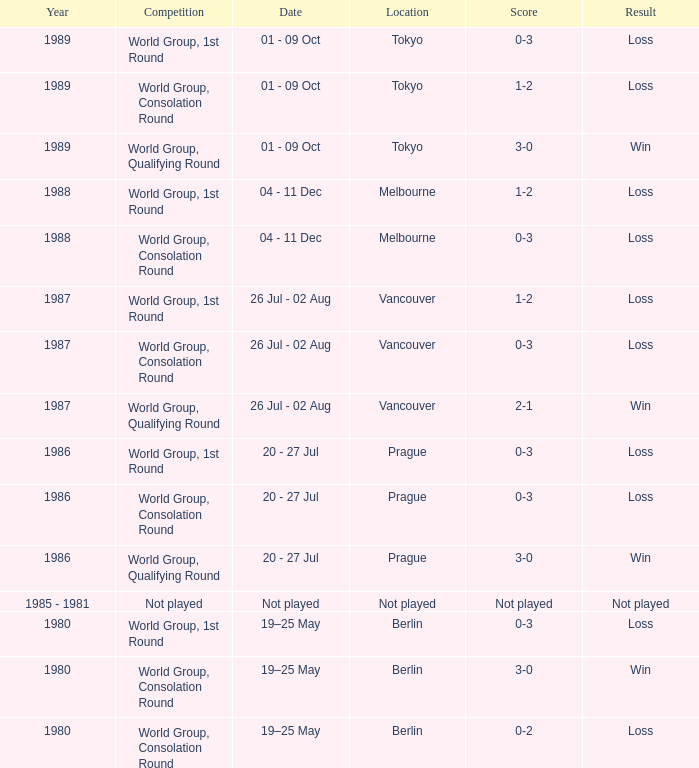What is the competition in tokyo with the result loss? World Group, 1st Round, World Group, Consolation Round. Would you be able to parse every entry in this table? {'header': ['Year', 'Competition', 'Date', 'Location', 'Score', 'Result'], 'rows': [['1989', 'World Group, 1st Round', '01 - 09 Oct', 'Tokyo', '0-3', 'Loss'], ['1989', 'World Group, Consolation Round', '01 - 09 Oct', 'Tokyo', '1-2', 'Loss'], ['1989', 'World Group, Qualifying Round', '01 - 09 Oct', 'Tokyo', '3-0', 'Win'], ['1988', 'World Group, 1st Round', '04 - 11 Dec', 'Melbourne', '1-2', 'Loss'], ['1988', 'World Group, Consolation Round', '04 - 11 Dec', 'Melbourne', '0-3', 'Loss'], ['1987', 'World Group, 1st Round', '26 Jul - 02 Aug', 'Vancouver', '1-2', 'Loss'], ['1987', 'World Group, Consolation Round', '26 Jul - 02 Aug', 'Vancouver', '0-3', 'Loss'], ['1987', 'World Group, Qualifying Round', '26 Jul - 02 Aug', 'Vancouver', '2-1', 'Win'], ['1986', 'World Group, 1st Round', '20 - 27 Jul', 'Prague', '0-3', 'Loss'], ['1986', 'World Group, Consolation Round', '20 - 27 Jul', 'Prague', '0-3', 'Loss'], ['1986', 'World Group, Qualifying Round', '20 - 27 Jul', 'Prague', '3-0', 'Win'], ['1985 - 1981', 'Not played', 'Not played', 'Not played', 'Not played', 'Not played'], ['1980', 'World Group, 1st Round', '19–25 May', 'Berlin', '0-3', 'Loss'], ['1980', 'World Group, Consolation Round', '19–25 May', 'Berlin', '3-0', 'Win'], ['1980', 'World Group, Consolation Round', '19–25 May', 'Berlin', '0-2', 'Loss']]} 